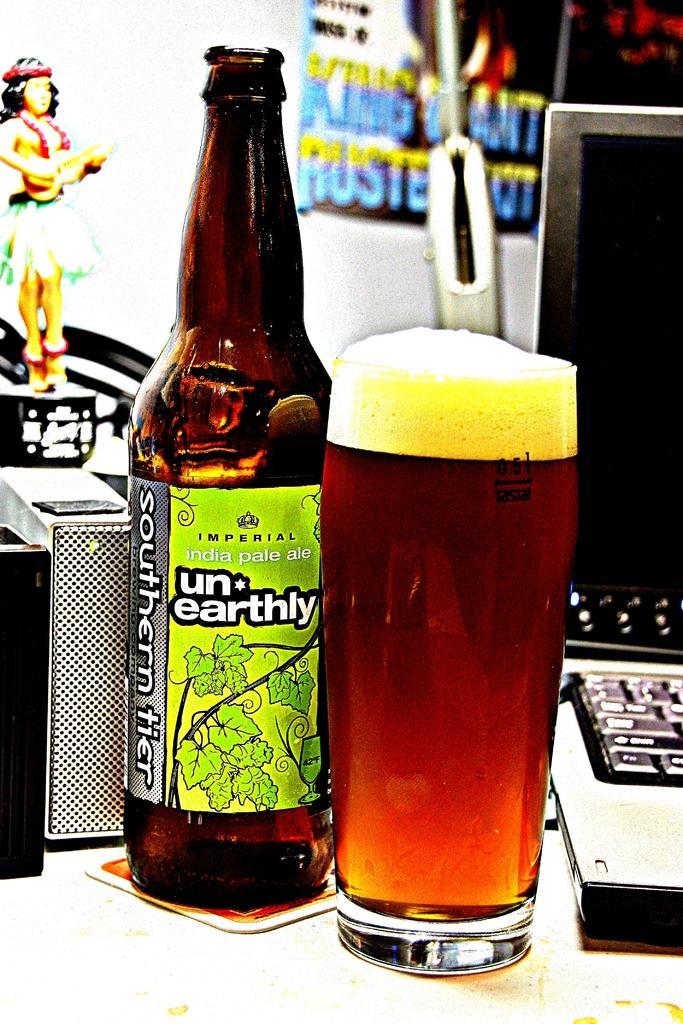Describe this image in one or two sentences. On the table we have bottle,glass,matchbox,laptop,toy is present,in the back there is poster. 